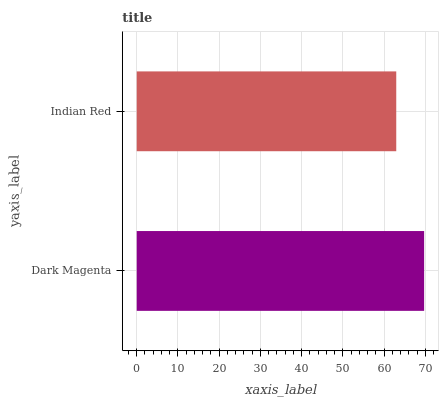Is Indian Red the minimum?
Answer yes or no. Yes. Is Dark Magenta the maximum?
Answer yes or no. Yes. Is Indian Red the maximum?
Answer yes or no. No. Is Dark Magenta greater than Indian Red?
Answer yes or no. Yes. Is Indian Red less than Dark Magenta?
Answer yes or no. Yes. Is Indian Red greater than Dark Magenta?
Answer yes or no. No. Is Dark Magenta less than Indian Red?
Answer yes or no. No. Is Dark Magenta the high median?
Answer yes or no. Yes. Is Indian Red the low median?
Answer yes or no. Yes. Is Indian Red the high median?
Answer yes or no. No. Is Dark Magenta the low median?
Answer yes or no. No. 